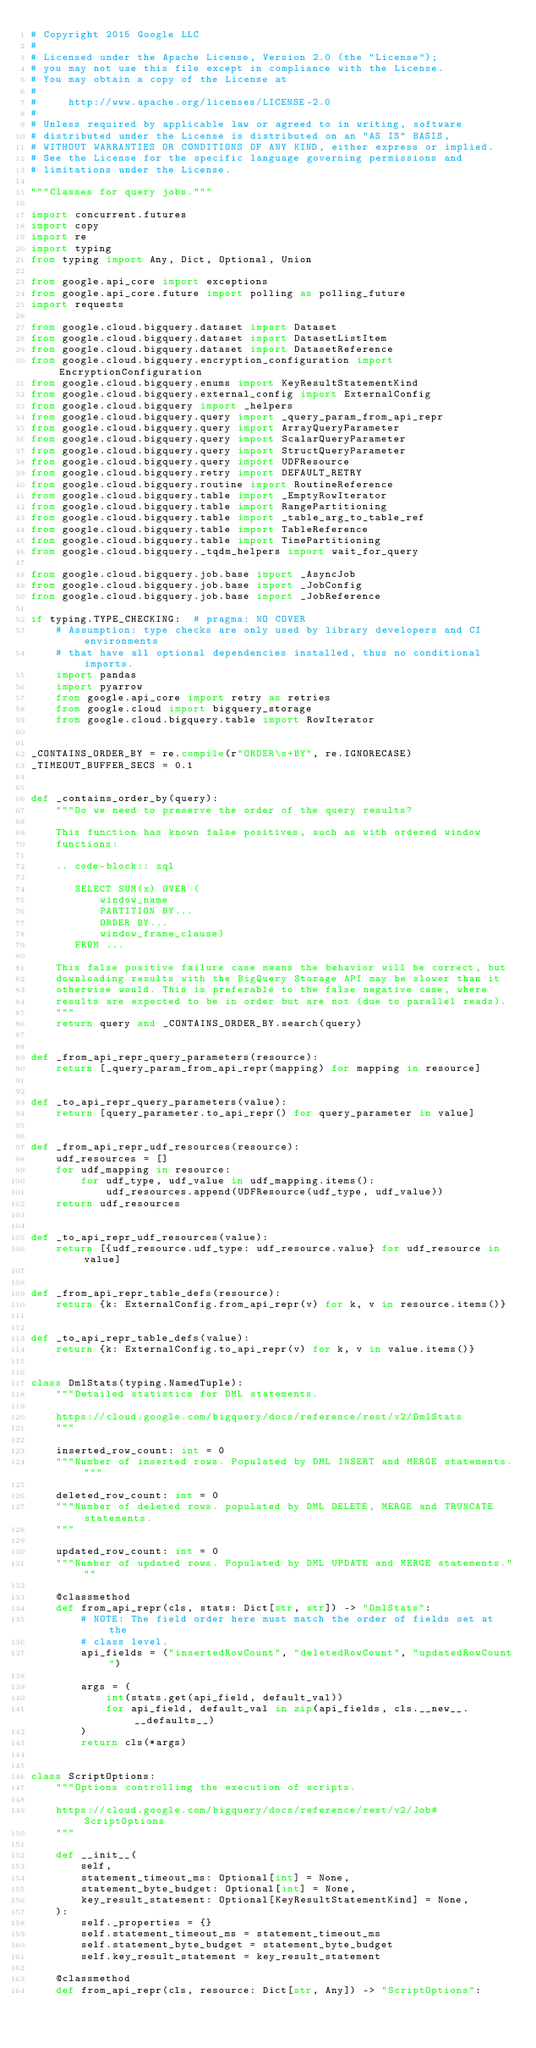<code> <loc_0><loc_0><loc_500><loc_500><_Python_># Copyright 2015 Google LLC
#
# Licensed under the Apache License, Version 2.0 (the "License");
# you may not use this file except in compliance with the License.
# You may obtain a copy of the License at
#
#     http://www.apache.org/licenses/LICENSE-2.0
#
# Unless required by applicable law or agreed to in writing, software
# distributed under the License is distributed on an "AS IS" BASIS,
# WITHOUT WARRANTIES OR CONDITIONS OF ANY KIND, either express or implied.
# See the License for the specific language governing permissions and
# limitations under the License.

"""Classes for query jobs."""

import concurrent.futures
import copy
import re
import typing
from typing import Any, Dict, Optional, Union

from google.api_core import exceptions
from google.api_core.future import polling as polling_future
import requests

from google.cloud.bigquery.dataset import Dataset
from google.cloud.bigquery.dataset import DatasetListItem
from google.cloud.bigquery.dataset import DatasetReference
from google.cloud.bigquery.encryption_configuration import EncryptionConfiguration
from google.cloud.bigquery.enums import KeyResultStatementKind
from google.cloud.bigquery.external_config import ExternalConfig
from google.cloud.bigquery import _helpers
from google.cloud.bigquery.query import _query_param_from_api_repr
from google.cloud.bigquery.query import ArrayQueryParameter
from google.cloud.bigquery.query import ScalarQueryParameter
from google.cloud.bigquery.query import StructQueryParameter
from google.cloud.bigquery.query import UDFResource
from google.cloud.bigquery.retry import DEFAULT_RETRY
from google.cloud.bigquery.routine import RoutineReference
from google.cloud.bigquery.table import _EmptyRowIterator
from google.cloud.bigquery.table import RangePartitioning
from google.cloud.bigquery.table import _table_arg_to_table_ref
from google.cloud.bigquery.table import TableReference
from google.cloud.bigquery.table import TimePartitioning
from google.cloud.bigquery._tqdm_helpers import wait_for_query

from google.cloud.bigquery.job.base import _AsyncJob
from google.cloud.bigquery.job.base import _JobConfig
from google.cloud.bigquery.job.base import _JobReference

if typing.TYPE_CHECKING:  # pragma: NO COVER
    # Assumption: type checks are only used by library developers and CI environments
    # that have all optional dependencies installed, thus no conditional imports.
    import pandas
    import pyarrow
    from google.api_core import retry as retries
    from google.cloud import bigquery_storage
    from google.cloud.bigquery.table import RowIterator


_CONTAINS_ORDER_BY = re.compile(r"ORDER\s+BY", re.IGNORECASE)
_TIMEOUT_BUFFER_SECS = 0.1


def _contains_order_by(query):
    """Do we need to preserve the order of the query results?

    This function has known false positives, such as with ordered window
    functions:

    .. code-block:: sql

       SELECT SUM(x) OVER (
           window_name
           PARTITION BY...
           ORDER BY...
           window_frame_clause)
       FROM ...

    This false positive failure case means the behavior will be correct, but
    downloading results with the BigQuery Storage API may be slower than it
    otherwise would. This is preferable to the false negative case, where
    results are expected to be in order but are not (due to parallel reads).
    """
    return query and _CONTAINS_ORDER_BY.search(query)


def _from_api_repr_query_parameters(resource):
    return [_query_param_from_api_repr(mapping) for mapping in resource]


def _to_api_repr_query_parameters(value):
    return [query_parameter.to_api_repr() for query_parameter in value]


def _from_api_repr_udf_resources(resource):
    udf_resources = []
    for udf_mapping in resource:
        for udf_type, udf_value in udf_mapping.items():
            udf_resources.append(UDFResource(udf_type, udf_value))
    return udf_resources


def _to_api_repr_udf_resources(value):
    return [{udf_resource.udf_type: udf_resource.value} for udf_resource in value]


def _from_api_repr_table_defs(resource):
    return {k: ExternalConfig.from_api_repr(v) for k, v in resource.items()}


def _to_api_repr_table_defs(value):
    return {k: ExternalConfig.to_api_repr(v) for k, v in value.items()}


class DmlStats(typing.NamedTuple):
    """Detailed statistics for DML statements.

    https://cloud.google.com/bigquery/docs/reference/rest/v2/DmlStats
    """

    inserted_row_count: int = 0
    """Number of inserted rows. Populated by DML INSERT and MERGE statements."""

    deleted_row_count: int = 0
    """Number of deleted rows. populated by DML DELETE, MERGE and TRUNCATE statements.
    """

    updated_row_count: int = 0
    """Number of updated rows. Populated by DML UPDATE and MERGE statements."""

    @classmethod
    def from_api_repr(cls, stats: Dict[str, str]) -> "DmlStats":
        # NOTE: The field order here must match the order of fields set at the
        # class level.
        api_fields = ("insertedRowCount", "deletedRowCount", "updatedRowCount")

        args = (
            int(stats.get(api_field, default_val))
            for api_field, default_val in zip(api_fields, cls.__new__.__defaults__)
        )
        return cls(*args)


class ScriptOptions:
    """Options controlling the execution of scripts.

    https://cloud.google.com/bigquery/docs/reference/rest/v2/Job#ScriptOptions
    """

    def __init__(
        self,
        statement_timeout_ms: Optional[int] = None,
        statement_byte_budget: Optional[int] = None,
        key_result_statement: Optional[KeyResultStatementKind] = None,
    ):
        self._properties = {}
        self.statement_timeout_ms = statement_timeout_ms
        self.statement_byte_budget = statement_byte_budget
        self.key_result_statement = key_result_statement

    @classmethod
    def from_api_repr(cls, resource: Dict[str, Any]) -> "ScriptOptions":</code> 